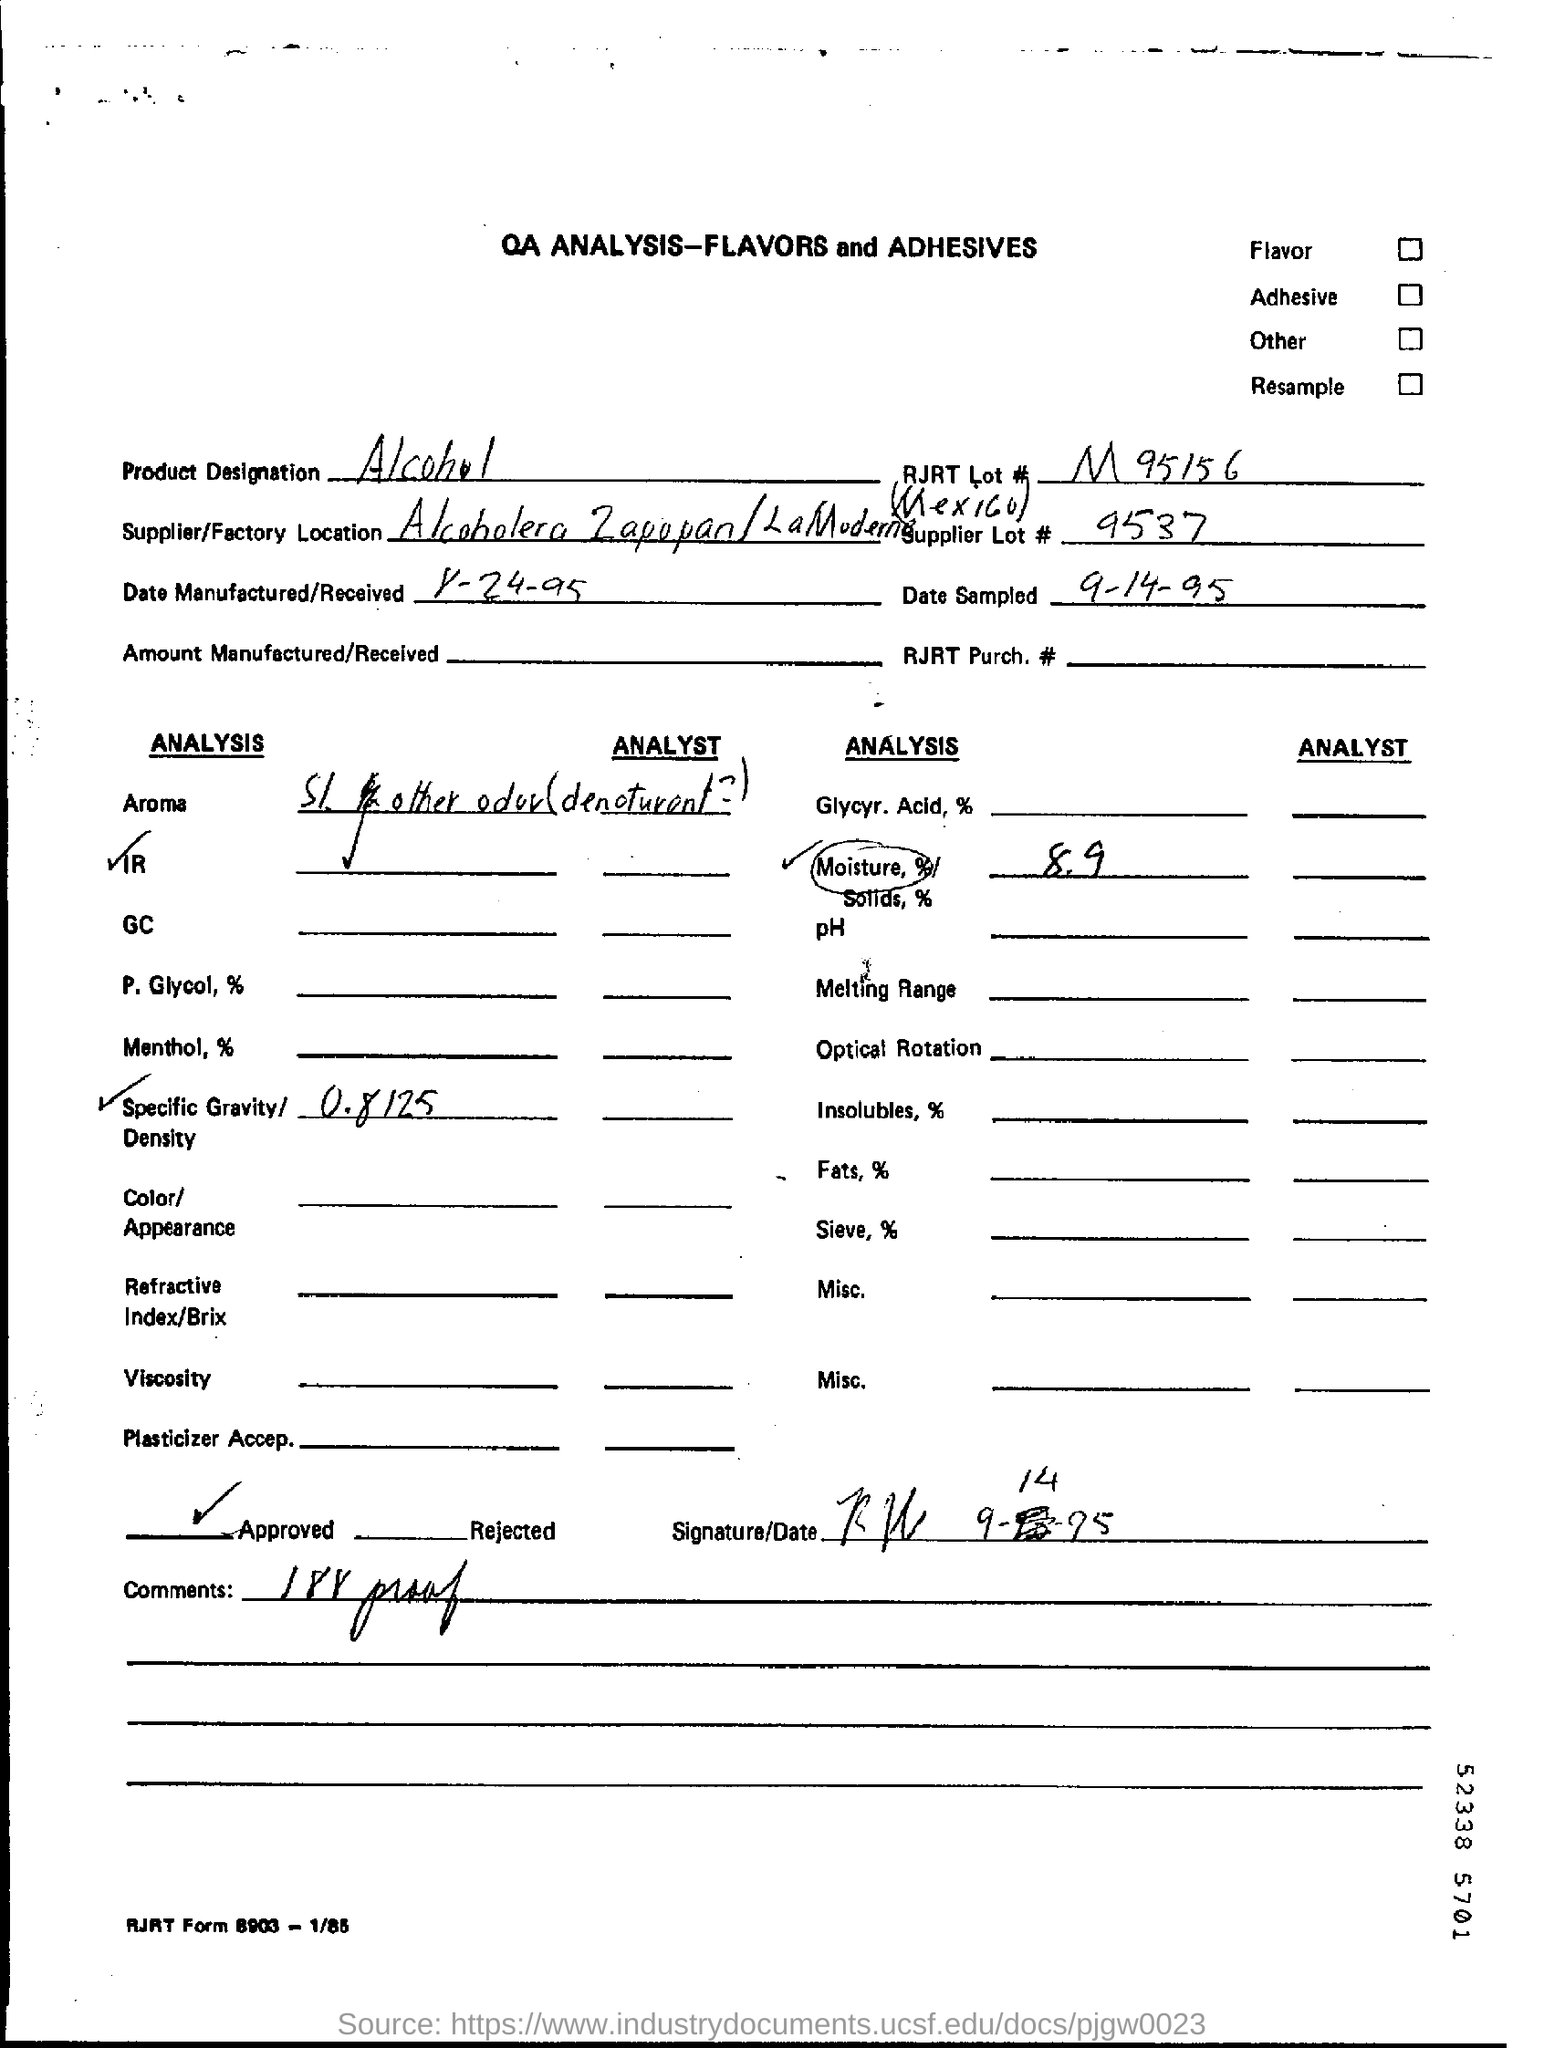Indicate a few pertinent items in this graphic. The moisture content is 8.9%. The product is designated as alcohol. The supplier's lot number is 9537. 